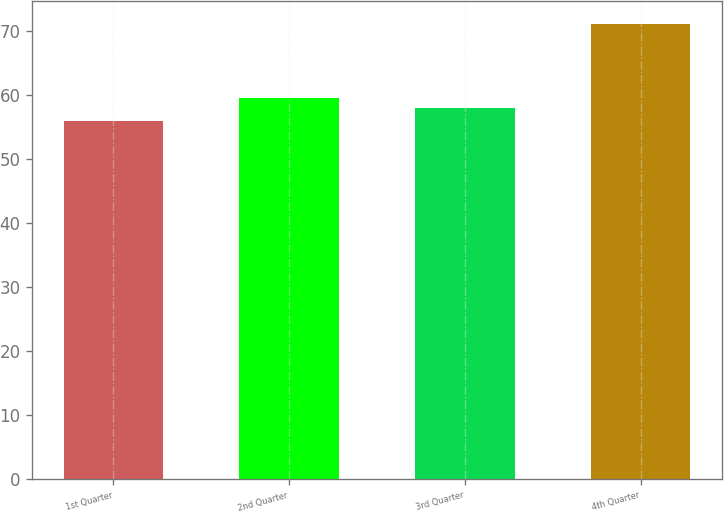<chart> <loc_0><loc_0><loc_500><loc_500><bar_chart><fcel>1st Quarter<fcel>2nd Quarter<fcel>3rd Quarter<fcel>4th Quarter<nl><fcel>55.99<fcel>59.46<fcel>57.95<fcel>71.11<nl></chart> 